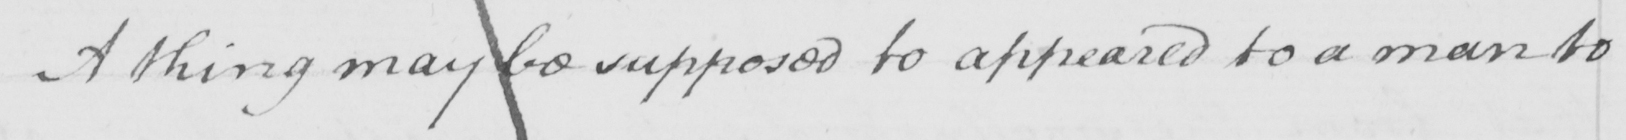What does this handwritten line say? A thing may be supposed to appeared to a man to 